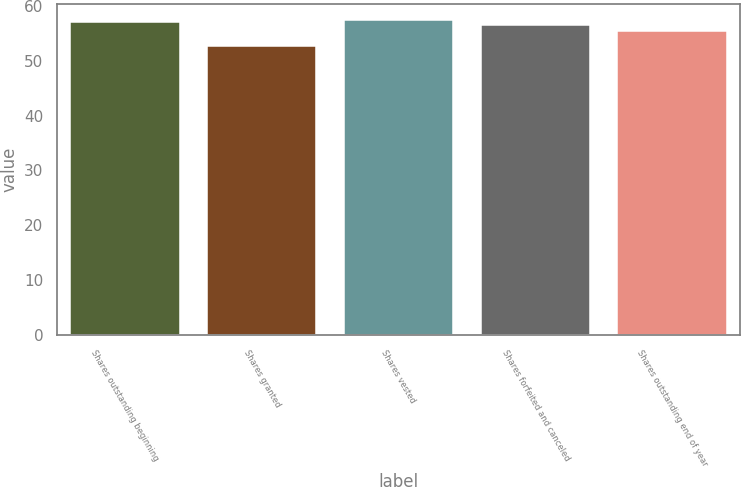Convert chart to OTSL. <chart><loc_0><loc_0><loc_500><loc_500><bar_chart><fcel>Shares outstanding beginning<fcel>Shares granted<fcel>Shares vested<fcel>Shares forfeited and canceled<fcel>Shares outstanding end of year<nl><fcel>57.08<fcel>52.72<fcel>57.52<fcel>56.44<fcel>55.5<nl></chart> 